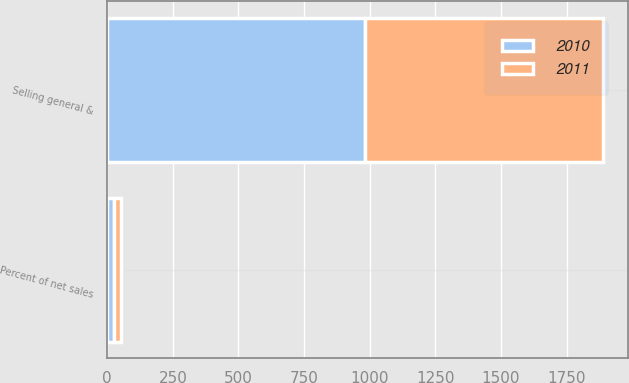Convert chart to OTSL. <chart><loc_0><loc_0><loc_500><loc_500><stacked_bar_chart><ecel><fcel>Selling general &<fcel>Percent of net sales<nl><fcel>2010<fcel>982.2<fcel>26.6<nl><fcel>2011<fcel>907.9<fcel>27.2<nl></chart> 